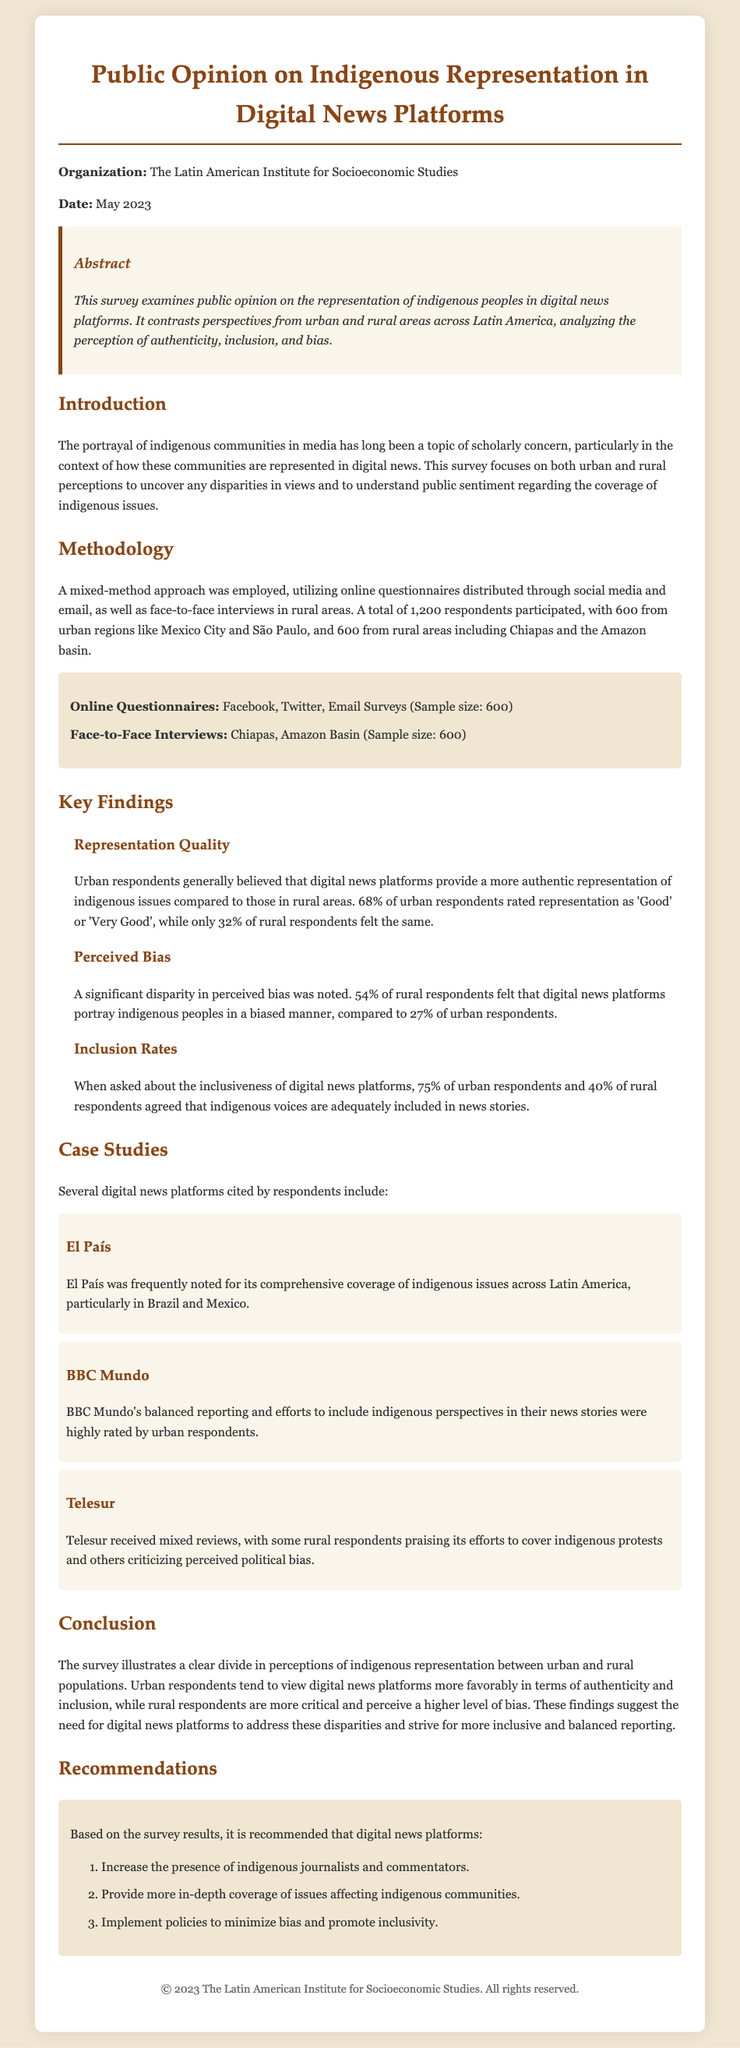what is the title of the survey? The title of the survey is explicitly stated at the top of the document.
Answer: Public Opinion on Indigenous Representation in Digital News Platforms how many respondents participated in the survey? The number of respondents is provided in the methodology section.
Answer: 1,200 what percentage of urban respondents rated representation as 'Good' or 'Very Good'? This percentage is specified in the findings section related to representation quality.
Answer: 68% which organization conducted the survey? The organization name is mentioned at the beginning of the document.
Answer: The Latin American Institute for Socioeconomic Studies what was the date of the survey? The date is listed beneath the organization name at the beginning of the document.
Answer: May 2023 how many rural respondents felt that digital news platforms portray indigenous peoples in a biased manner? This specific number is provided in the perceived bias finding.
Answer: 54% what is one recommendation based on the survey results? Recommendations are summarized at the end of the document.
Answer: Increase the presence of indigenous journalists and commentators what regions were included for face-to-face interviews? The regions are mentioned in the methodology section.
Answer: Chiapas and the Amazon Basin how does the perception of bias differ between urban and rural respondents? This comparison is made in the perceived bias finding, detailing the different perceptions.
Answer: Rural respondents are more critical and perceive a higher level of bias 